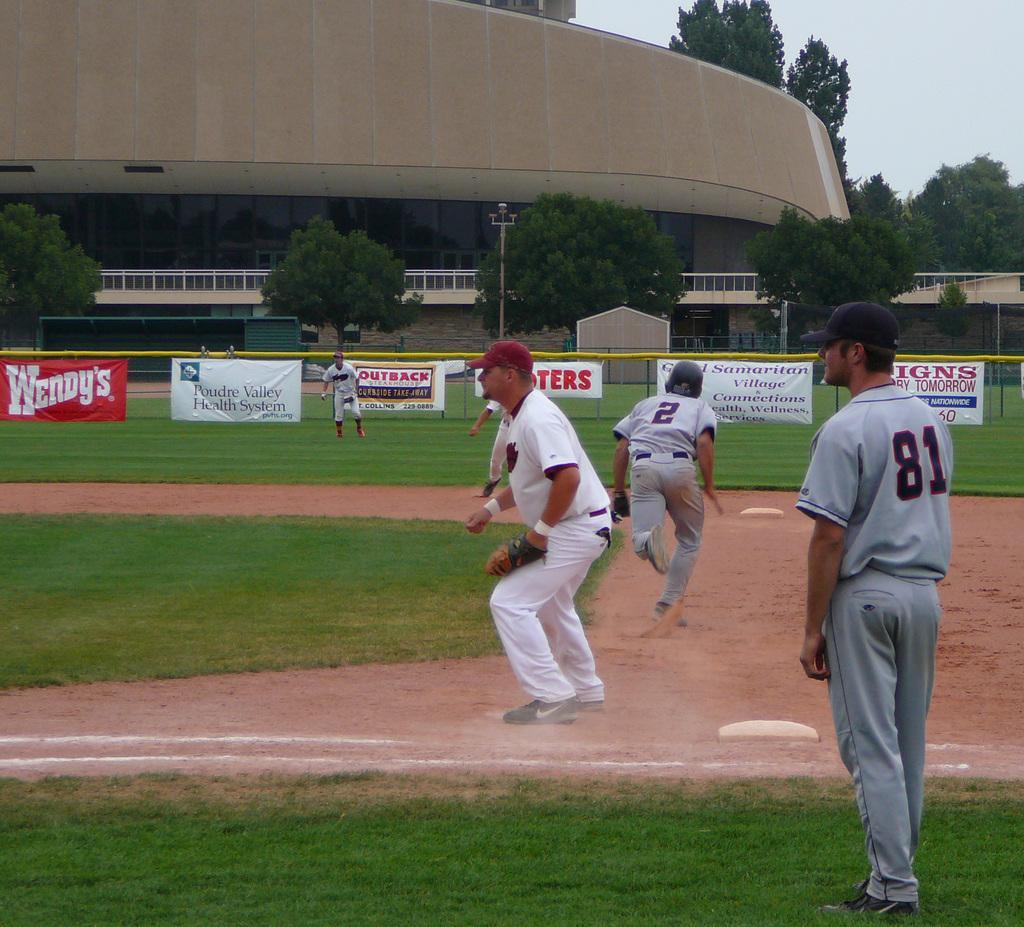Describe this image in one or two sentences. This picture is clicked outside. On the right we can see the group of persons wearing t-shirts and seems to be running on the ground. On the right corner we can see a person wearing t-shirt and standing on the ground and we can see the green grass, metal rods and the text on the banners. In the background we can see the sky, trees, building, metal rods and some other objects and we can see a pole. 